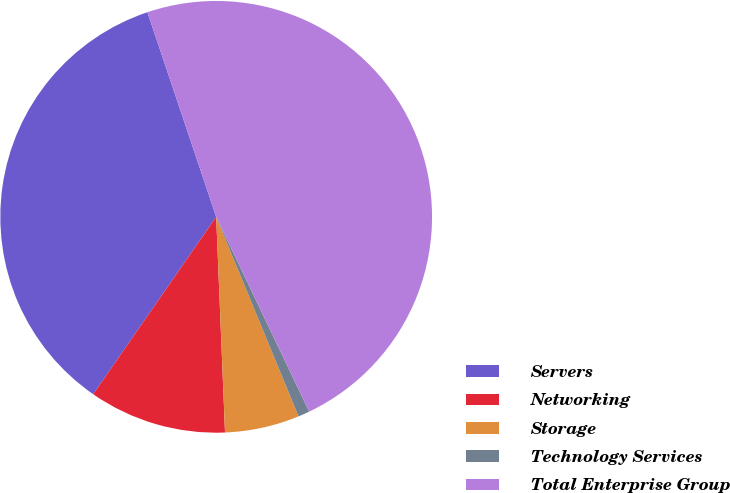<chart> <loc_0><loc_0><loc_500><loc_500><pie_chart><fcel>Servers<fcel>Networking<fcel>Storage<fcel>Technology Services<fcel>Total Enterprise Group<nl><fcel>35.19%<fcel>10.3%<fcel>5.58%<fcel>0.86%<fcel>48.07%<nl></chart> 